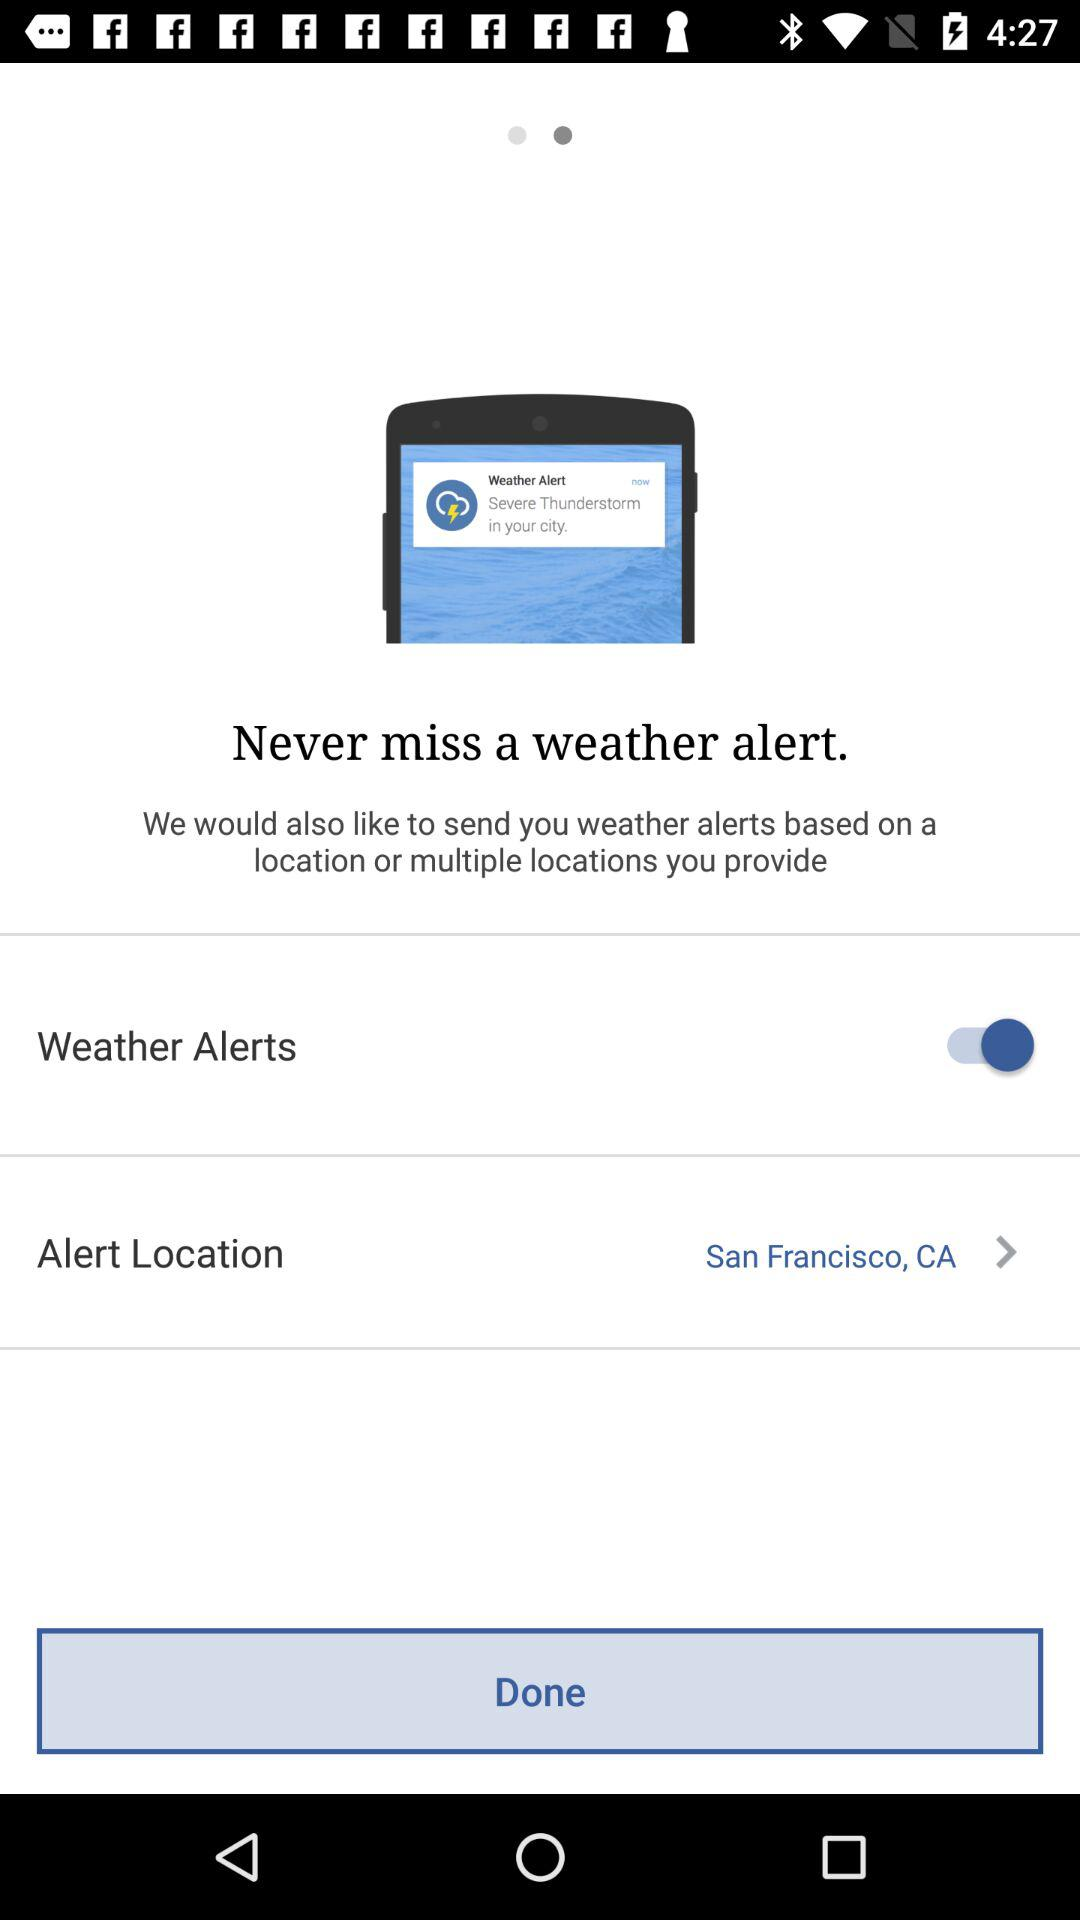What is the status of the "Weather Alerts"? The status is "on". 